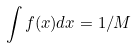Convert formula to latex. <formula><loc_0><loc_0><loc_500><loc_500>\int f ( x ) d x = 1 / M</formula> 